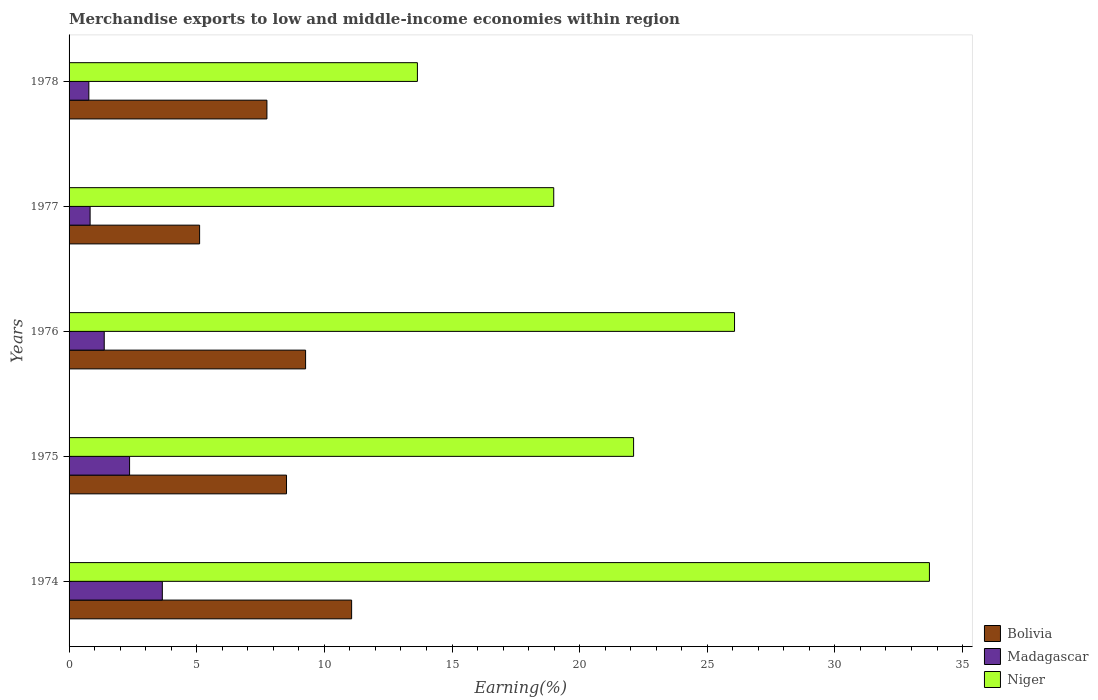Are the number of bars per tick equal to the number of legend labels?
Offer a terse response. Yes. How many bars are there on the 3rd tick from the top?
Offer a terse response. 3. What is the label of the 1st group of bars from the top?
Offer a very short reply. 1978. In how many cases, is the number of bars for a given year not equal to the number of legend labels?
Your response must be concise. 0. What is the percentage of amount earned from merchandise exports in Madagascar in 1978?
Offer a very short reply. 0.77. Across all years, what is the maximum percentage of amount earned from merchandise exports in Niger?
Your answer should be very brief. 33.7. Across all years, what is the minimum percentage of amount earned from merchandise exports in Bolivia?
Give a very brief answer. 5.11. In which year was the percentage of amount earned from merchandise exports in Bolivia maximum?
Make the answer very short. 1974. In which year was the percentage of amount earned from merchandise exports in Madagascar minimum?
Provide a succinct answer. 1978. What is the total percentage of amount earned from merchandise exports in Madagascar in the graph?
Ensure brevity in your answer.  9. What is the difference between the percentage of amount earned from merchandise exports in Niger in 1975 and that in 1978?
Your answer should be compact. 8.47. What is the difference between the percentage of amount earned from merchandise exports in Bolivia in 1976 and the percentage of amount earned from merchandise exports in Madagascar in 1974?
Your answer should be very brief. 5.61. What is the average percentage of amount earned from merchandise exports in Bolivia per year?
Keep it short and to the point. 8.34. In the year 1975, what is the difference between the percentage of amount earned from merchandise exports in Bolivia and percentage of amount earned from merchandise exports in Madagascar?
Give a very brief answer. 6.15. In how many years, is the percentage of amount earned from merchandise exports in Madagascar greater than 32 %?
Your answer should be very brief. 0. What is the ratio of the percentage of amount earned from merchandise exports in Bolivia in 1974 to that in 1975?
Make the answer very short. 1.3. Is the percentage of amount earned from merchandise exports in Madagascar in 1974 less than that in 1978?
Give a very brief answer. No. Is the difference between the percentage of amount earned from merchandise exports in Bolivia in 1975 and 1977 greater than the difference between the percentage of amount earned from merchandise exports in Madagascar in 1975 and 1977?
Give a very brief answer. Yes. What is the difference between the highest and the second highest percentage of amount earned from merchandise exports in Madagascar?
Ensure brevity in your answer.  1.28. What is the difference between the highest and the lowest percentage of amount earned from merchandise exports in Bolivia?
Keep it short and to the point. 5.95. What does the 1st bar from the top in 1975 represents?
Ensure brevity in your answer.  Niger. What does the 2nd bar from the bottom in 1978 represents?
Give a very brief answer. Madagascar. How many bars are there?
Offer a terse response. 15. Are all the bars in the graph horizontal?
Your answer should be very brief. Yes. How are the legend labels stacked?
Offer a terse response. Vertical. What is the title of the graph?
Ensure brevity in your answer.  Merchandise exports to low and middle-income economies within region. Does "Venezuela" appear as one of the legend labels in the graph?
Provide a succinct answer. No. What is the label or title of the X-axis?
Provide a succinct answer. Earning(%). What is the Earning(%) of Bolivia in 1974?
Keep it short and to the point. 11.07. What is the Earning(%) of Madagascar in 1974?
Ensure brevity in your answer.  3.65. What is the Earning(%) of Niger in 1974?
Give a very brief answer. 33.7. What is the Earning(%) in Bolivia in 1975?
Keep it short and to the point. 8.52. What is the Earning(%) of Madagascar in 1975?
Keep it short and to the point. 2.37. What is the Earning(%) of Niger in 1975?
Keep it short and to the point. 22.11. What is the Earning(%) in Bolivia in 1976?
Your answer should be compact. 9.27. What is the Earning(%) in Madagascar in 1976?
Offer a very short reply. 1.38. What is the Earning(%) in Niger in 1976?
Keep it short and to the point. 26.07. What is the Earning(%) in Bolivia in 1977?
Ensure brevity in your answer.  5.11. What is the Earning(%) of Madagascar in 1977?
Your response must be concise. 0.82. What is the Earning(%) of Niger in 1977?
Your answer should be compact. 18.99. What is the Earning(%) in Bolivia in 1978?
Give a very brief answer. 7.75. What is the Earning(%) of Madagascar in 1978?
Offer a terse response. 0.77. What is the Earning(%) of Niger in 1978?
Provide a short and direct response. 13.64. Across all years, what is the maximum Earning(%) in Bolivia?
Provide a succinct answer. 11.07. Across all years, what is the maximum Earning(%) in Madagascar?
Provide a short and direct response. 3.65. Across all years, what is the maximum Earning(%) in Niger?
Your response must be concise. 33.7. Across all years, what is the minimum Earning(%) of Bolivia?
Make the answer very short. 5.11. Across all years, what is the minimum Earning(%) in Madagascar?
Offer a terse response. 0.77. Across all years, what is the minimum Earning(%) in Niger?
Provide a succinct answer. 13.64. What is the total Earning(%) in Bolivia in the graph?
Keep it short and to the point. 41.71. What is the total Earning(%) in Madagascar in the graph?
Give a very brief answer. 9. What is the total Earning(%) of Niger in the graph?
Your answer should be very brief. 114.51. What is the difference between the Earning(%) in Bolivia in 1974 and that in 1975?
Give a very brief answer. 2.55. What is the difference between the Earning(%) in Madagascar in 1974 and that in 1975?
Offer a terse response. 1.28. What is the difference between the Earning(%) in Niger in 1974 and that in 1975?
Make the answer very short. 11.59. What is the difference between the Earning(%) in Bolivia in 1974 and that in 1976?
Ensure brevity in your answer.  1.8. What is the difference between the Earning(%) of Madagascar in 1974 and that in 1976?
Make the answer very short. 2.28. What is the difference between the Earning(%) in Niger in 1974 and that in 1976?
Keep it short and to the point. 7.63. What is the difference between the Earning(%) in Bolivia in 1974 and that in 1977?
Your answer should be compact. 5.95. What is the difference between the Earning(%) in Madagascar in 1974 and that in 1977?
Keep it short and to the point. 2.83. What is the difference between the Earning(%) of Niger in 1974 and that in 1977?
Offer a very short reply. 14.72. What is the difference between the Earning(%) in Bolivia in 1974 and that in 1978?
Provide a succinct answer. 3.32. What is the difference between the Earning(%) of Madagascar in 1974 and that in 1978?
Offer a terse response. 2.88. What is the difference between the Earning(%) of Niger in 1974 and that in 1978?
Make the answer very short. 20.06. What is the difference between the Earning(%) in Bolivia in 1975 and that in 1976?
Your answer should be very brief. -0.75. What is the difference between the Earning(%) in Niger in 1975 and that in 1976?
Offer a terse response. -3.95. What is the difference between the Earning(%) of Bolivia in 1975 and that in 1977?
Provide a short and direct response. 3.4. What is the difference between the Earning(%) in Madagascar in 1975 and that in 1977?
Your response must be concise. 1.55. What is the difference between the Earning(%) in Niger in 1975 and that in 1977?
Your answer should be very brief. 3.13. What is the difference between the Earning(%) in Bolivia in 1975 and that in 1978?
Make the answer very short. 0.77. What is the difference between the Earning(%) in Madagascar in 1975 and that in 1978?
Provide a succinct answer. 1.6. What is the difference between the Earning(%) of Niger in 1975 and that in 1978?
Offer a terse response. 8.47. What is the difference between the Earning(%) in Bolivia in 1976 and that in 1977?
Make the answer very short. 4.15. What is the difference between the Earning(%) of Madagascar in 1976 and that in 1977?
Keep it short and to the point. 0.55. What is the difference between the Earning(%) in Niger in 1976 and that in 1977?
Give a very brief answer. 7.08. What is the difference between the Earning(%) of Bolivia in 1976 and that in 1978?
Provide a short and direct response. 1.51. What is the difference between the Earning(%) of Madagascar in 1976 and that in 1978?
Ensure brevity in your answer.  0.6. What is the difference between the Earning(%) in Niger in 1976 and that in 1978?
Provide a short and direct response. 12.42. What is the difference between the Earning(%) in Bolivia in 1977 and that in 1978?
Your answer should be compact. -2.64. What is the difference between the Earning(%) of Madagascar in 1977 and that in 1978?
Your answer should be very brief. 0.05. What is the difference between the Earning(%) in Niger in 1977 and that in 1978?
Offer a very short reply. 5.34. What is the difference between the Earning(%) in Bolivia in 1974 and the Earning(%) in Madagascar in 1975?
Your answer should be compact. 8.7. What is the difference between the Earning(%) in Bolivia in 1974 and the Earning(%) in Niger in 1975?
Offer a very short reply. -11.05. What is the difference between the Earning(%) of Madagascar in 1974 and the Earning(%) of Niger in 1975?
Your response must be concise. -18.46. What is the difference between the Earning(%) of Bolivia in 1974 and the Earning(%) of Madagascar in 1976?
Provide a short and direct response. 9.69. What is the difference between the Earning(%) of Bolivia in 1974 and the Earning(%) of Niger in 1976?
Your answer should be compact. -15. What is the difference between the Earning(%) of Madagascar in 1974 and the Earning(%) of Niger in 1976?
Keep it short and to the point. -22.41. What is the difference between the Earning(%) of Bolivia in 1974 and the Earning(%) of Madagascar in 1977?
Provide a short and direct response. 10.24. What is the difference between the Earning(%) of Bolivia in 1974 and the Earning(%) of Niger in 1977?
Your answer should be compact. -7.92. What is the difference between the Earning(%) of Madagascar in 1974 and the Earning(%) of Niger in 1977?
Your answer should be very brief. -15.33. What is the difference between the Earning(%) in Bolivia in 1974 and the Earning(%) in Madagascar in 1978?
Offer a terse response. 10.29. What is the difference between the Earning(%) of Bolivia in 1974 and the Earning(%) of Niger in 1978?
Your response must be concise. -2.58. What is the difference between the Earning(%) of Madagascar in 1974 and the Earning(%) of Niger in 1978?
Provide a succinct answer. -9.99. What is the difference between the Earning(%) of Bolivia in 1975 and the Earning(%) of Madagascar in 1976?
Provide a short and direct response. 7.14. What is the difference between the Earning(%) of Bolivia in 1975 and the Earning(%) of Niger in 1976?
Provide a succinct answer. -17.55. What is the difference between the Earning(%) of Madagascar in 1975 and the Earning(%) of Niger in 1976?
Offer a terse response. -23.7. What is the difference between the Earning(%) in Bolivia in 1975 and the Earning(%) in Madagascar in 1977?
Ensure brevity in your answer.  7.69. What is the difference between the Earning(%) in Bolivia in 1975 and the Earning(%) in Niger in 1977?
Ensure brevity in your answer.  -10.47. What is the difference between the Earning(%) of Madagascar in 1975 and the Earning(%) of Niger in 1977?
Your answer should be compact. -16.61. What is the difference between the Earning(%) of Bolivia in 1975 and the Earning(%) of Madagascar in 1978?
Your response must be concise. 7.74. What is the difference between the Earning(%) of Bolivia in 1975 and the Earning(%) of Niger in 1978?
Your response must be concise. -5.13. What is the difference between the Earning(%) of Madagascar in 1975 and the Earning(%) of Niger in 1978?
Offer a terse response. -11.27. What is the difference between the Earning(%) in Bolivia in 1976 and the Earning(%) in Madagascar in 1977?
Give a very brief answer. 8.44. What is the difference between the Earning(%) of Bolivia in 1976 and the Earning(%) of Niger in 1977?
Offer a very short reply. -9.72. What is the difference between the Earning(%) in Madagascar in 1976 and the Earning(%) in Niger in 1977?
Your response must be concise. -17.61. What is the difference between the Earning(%) in Bolivia in 1976 and the Earning(%) in Madagascar in 1978?
Offer a terse response. 8.49. What is the difference between the Earning(%) in Bolivia in 1976 and the Earning(%) in Niger in 1978?
Provide a short and direct response. -4.38. What is the difference between the Earning(%) in Madagascar in 1976 and the Earning(%) in Niger in 1978?
Your answer should be very brief. -12.27. What is the difference between the Earning(%) in Bolivia in 1977 and the Earning(%) in Madagascar in 1978?
Make the answer very short. 4.34. What is the difference between the Earning(%) of Bolivia in 1977 and the Earning(%) of Niger in 1978?
Provide a succinct answer. -8.53. What is the difference between the Earning(%) of Madagascar in 1977 and the Earning(%) of Niger in 1978?
Your answer should be very brief. -12.82. What is the average Earning(%) of Bolivia per year?
Offer a terse response. 8.34. What is the average Earning(%) of Madagascar per year?
Your answer should be very brief. 1.8. What is the average Earning(%) in Niger per year?
Provide a short and direct response. 22.9. In the year 1974, what is the difference between the Earning(%) in Bolivia and Earning(%) in Madagascar?
Keep it short and to the point. 7.42. In the year 1974, what is the difference between the Earning(%) of Bolivia and Earning(%) of Niger?
Ensure brevity in your answer.  -22.63. In the year 1974, what is the difference between the Earning(%) in Madagascar and Earning(%) in Niger?
Provide a short and direct response. -30.05. In the year 1975, what is the difference between the Earning(%) in Bolivia and Earning(%) in Madagascar?
Keep it short and to the point. 6.15. In the year 1975, what is the difference between the Earning(%) in Bolivia and Earning(%) in Niger?
Give a very brief answer. -13.6. In the year 1975, what is the difference between the Earning(%) of Madagascar and Earning(%) of Niger?
Your response must be concise. -19.74. In the year 1976, what is the difference between the Earning(%) of Bolivia and Earning(%) of Madagascar?
Give a very brief answer. 7.89. In the year 1976, what is the difference between the Earning(%) of Bolivia and Earning(%) of Niger?
Give a very brief answer. -16.8. In the year 1976, what is the difference between the Earning(%) of Madagascar and Earning(%) of Niger?
Give a very brief answer. -24.69. In the year 1977, what is the difference between the Earning(%) in Bolivia and Earning(%) in Madagascar?
Offer a terse response. 4.29. In the year 1977, what is the difference between the Earning(%) of Bolivia and Earning(%) of Niger?
Keep it short and to the point. -13.87. In the year 1977, what is the difference between the Earning(%) of Madagascar and Earning(%) of Niger?
Make the answer very short. -18.16. In the year 1978, what is the difference between the Earning(%) in Bolivia and Earning(%) in Madagascar?
Your answer should be compact. 6.98. In the year 1978, what is the difference between the Earning(%) in Bolivia and Earning(%) in Niger?
Provide a succinct answer. -5.89. In the year 1978, what is the difference between the Earning(%) of Madagascar and Earning(%) of Niger?
Make the answer very short. -12.87. What is the ratio of the Earning(%) in Bolivia in 1974 to that in 1975?
Offer a terse response. 1.3. What is the ratio of the Earning(%) in Madagascar in 1974 to that in 1975?
Offer a terse response. 1.54. What is the ratio of the Earning(%) in Niger in 1974 to that in 1975?
Keep it short and to the point. 1.52. What is the ratio of the Earning(%) of Bolivia in 1974 to that in 1976?
Offer a very short reply. 1.19. What is the ratio of the Earning(%) of Madagascar in 1974 to that in 1976?
Your answer should be very brief. 2.65. What is the ratio of the Earning(%) in Niger in 1974 to that in 1976?
Your answer should be compact. 1.29. What is the ratio of the Earning(%) in Bolivia in 1974 to that in 1977?
Give a very brief answer. 2.16. What is the ratio of the Earning(%) of Madagascar in 1974 to that in 1977?
Offer a very short reply. 4.43. What is the ratio of the Earning(%) in Niger in 1974 to that in 1977?
Your answer should be compact. 1.78. What is the ratio of the Earning(%) of Bolivia in 1974 to that in 1978?
Your response must be concise. 1.43. What is the ratio of the Earning(%) of Madagascar in 1974 to that in 1978?
Your response must be concise. 4.72. What is the ratio of the Earning(%) of Niger in 1974 to that in 1978?
Offer a terse response. 2.47. What is the ratio of the Earning(%) in Bolivia in 1975 to that in 1976?
Your response must be concise. 0.92. What is the ratio of the Earning(%) of Madagascar in 1975 to that in 1976?
Offer a terse response. 1.72. What is the ratio of the Earning(%) in Niger in 1975 to that in 1976?
Provide a short and direct response. 0.85. What is the ratio of the Earning(%) of Bolivia in 1975 to that in 1977?
Give a very brief answer. 1.67. What is the ratio of the Earning(%) of Madagascar in 1975 to that in 1977?
Your answer should be very brief. 2.88. What is the ratio of the Earning(%) of Niger in 1975 to that in 1977?
Give a very brief answer. 1.16. What is the ratio of the Earning(%) in Bolivia in 1975 to that in 1978?
Offer a very short reply. 1.1. What is the ratio of the Earning(%) in Madagascar in 1975 to that in 1978?
Provide a succinct answer. 3.06. What is the ratio of the Earning(%) of Niger in 1975 to that in 1978?
Provide a succinct answer. 1.62. What is the ratio of the Earning(%) in Bolivia in 1976 to that in 1977?
Give a very brief answer. 1.81. What is the ratio of the Earning(%) in Madagascar in 1976 to that in 1977?
Your response must be concise. 1.67. What is the ratio of the Earning(%) in Niger in 1976 to that in 1977?
Your answer should be very brief. 1.37. What is the ratio of the Earning(%) in Bolivia in 1976 to that in 1978?
Your response must be concise. 1.2. What is the ratio of the Earning(%) in Madagascar in 1976 to that in 1978?
Provide a short and direct response. 1.78. What is the ratio of the Earning(%) in Niger in 1976 to that in 1978?
Ensure brevity in your answer.  1.91. What is the ratio of the Earning(%) of Bolivia in 1977 to that in 1978?
Your answer should be very brief. 0.66. What is the ratio of the Earning(%) of Madagascar in 1977 to that in 1978?
Keep it short and to the point. 1.06. What is the ratio of the Earning(%) in Niger in 1977 to that in 1978?
Your answer should be compact. 1.39. What is the difference between the highest and the second highest Earning(%) in Bolivia?
Your answer should be very brief. 1.8. What is the difference between the highest and the second highest Earning(%) in Madagascar?
Your answer should be compact. 1.28. What is the difference between the highest and the second highest Earning(%) in Niger?
Make the answer very short. 7.63. What is the difference between the highest and the lowest Earning(%) of Bolivia?
Ensure brevity in your answer.  5.95. What is the difference between the highest and the lowest Earning(%) in Madagascar?
Offer a terse response. 2.88. What is the difference between the highest and the lowest Earning(%) of Niger?
Your answer should be very brief. 20.06. 